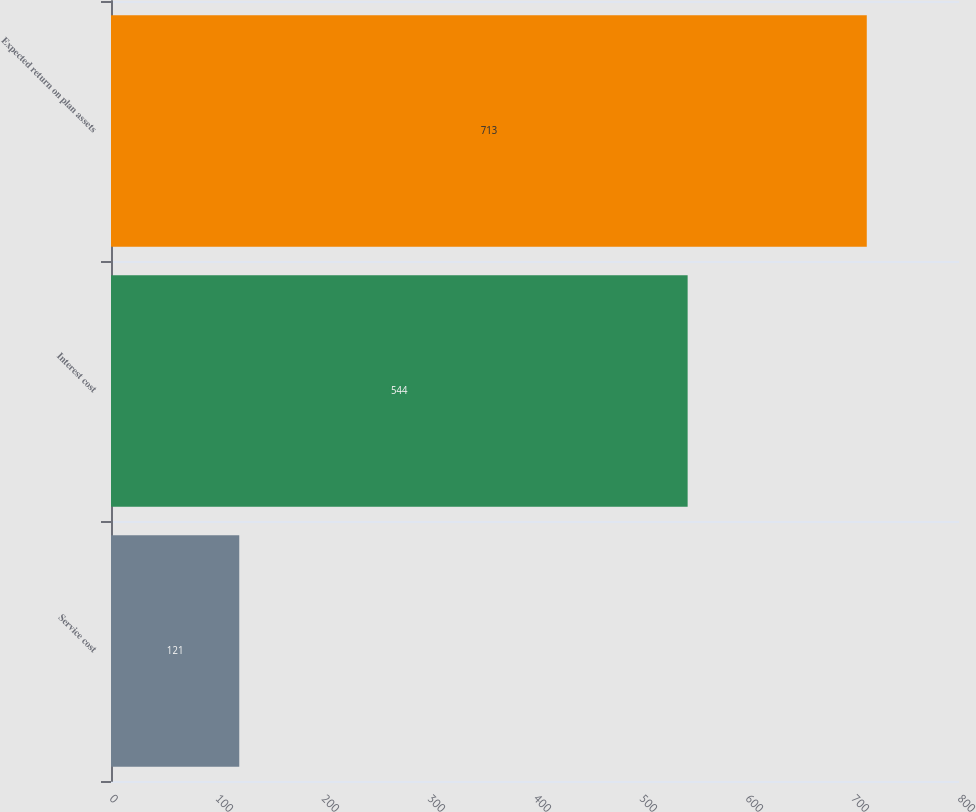Convert chart. <chart><loc_0><loc_0><loc_500><loc_500><bar_chart><fcel>Service cost<fcel>Interest cost<fcel>Expected return on plan assets<nl><fcel>121<fcel>544<fcel>713<nl></chart> 